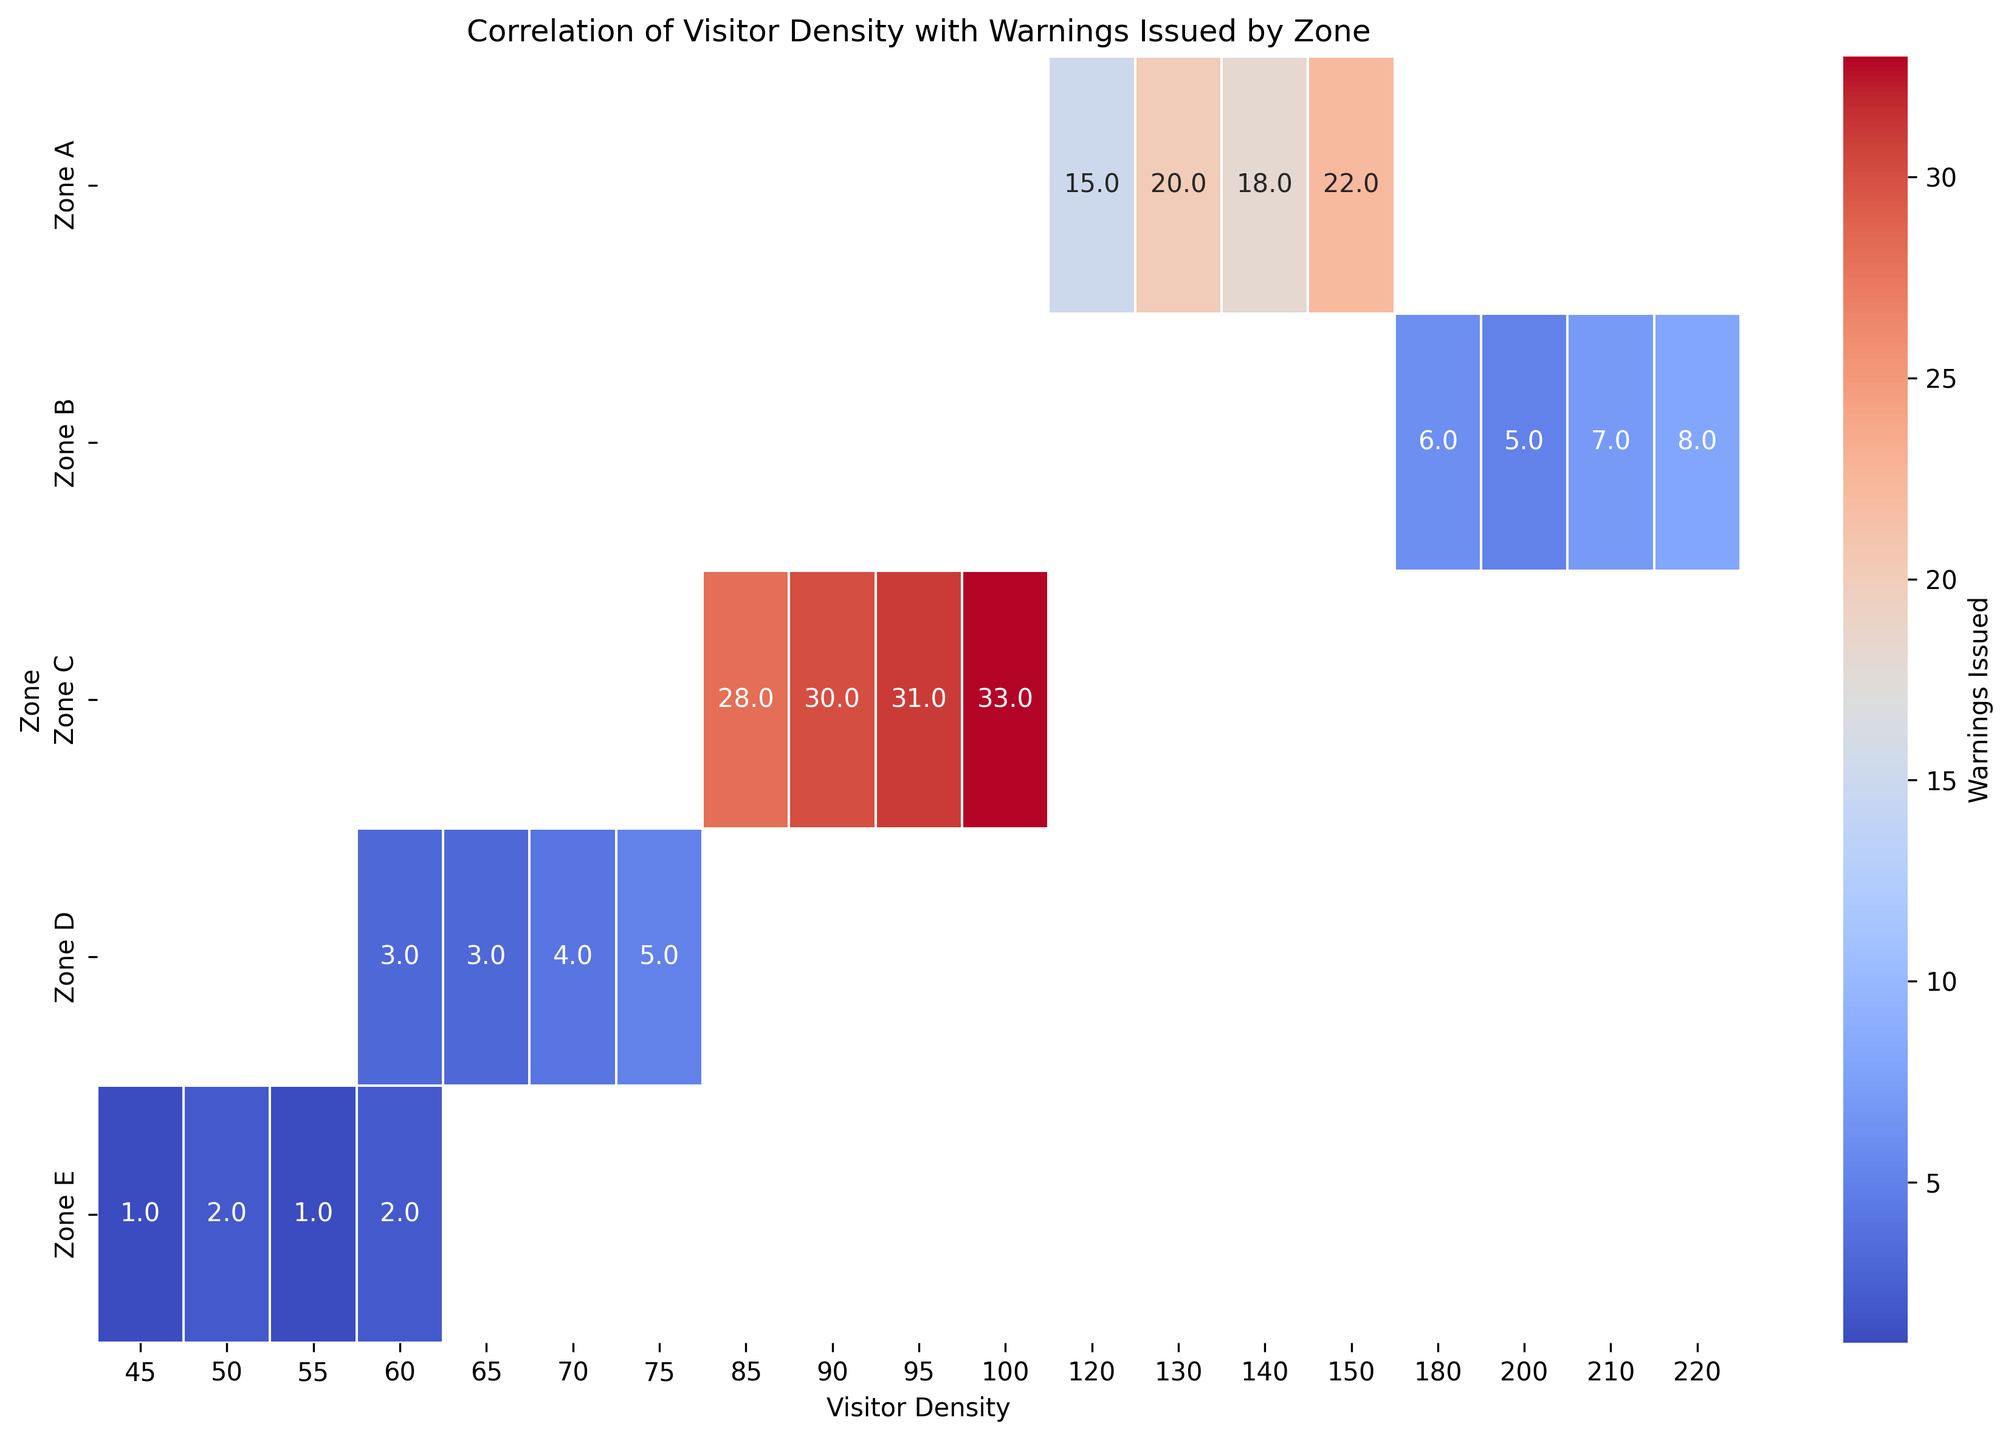Which zone has the highest average warnings issued? By looking at the heatmap, we can identify the average number of warnings issued for each zone by examining the color intensity and numerical values annotated in the cells. Zone C consistently has higher warning values compared to other zones.
Answer: Zone C In Zone B, which visitor density level corresponds to the highest number of warnings issued? We need to locate Zone B on the y-axis and find the cell with the highest numeric value for warnings issued across different visitor density levels. The highest value for Zone B is 220 visitor density with 8 warnings issued.
Answer: 220 How does the number of warnings issued in Zone D for 60 visitor density compare to 70 visitor density? By observing the cells in Zone D row corresponding to 60 and 70 visitor densities, we can compare the numbers. For 60 visitor density, 3 warnings are issued; for 70 visitor density, 4 warnings are issued. So, 4 is greater than 3.
Answer: 4 warnings is higher than 3 warnings What is the approximate average number of warnings issued in Zone A? We can calculate the average by summing the warnings for Zone A and dividing by the number of entries. The warnings are 15, 18, 20, 22. The sum is 15 + 18 + 20 + 22 = 75. The average is 75 / 4 = 18.75 warnings.
Answer: 18.75 Between Zones C and E, which has the higher median number of warnings issued? We identify the warnings for each Zone and calculate the median. Zone C: 30, 28, 33, 31; median is (30 + 31) / 2 = 30.5. Zone E: 2, 1, 1, 2; median is (1 + 2) / 2 = 1.5. Zone C has a higher median warning number.
Answer: Zone C What color gradient represents the highest number of warnings issued in the heatmap? By understanding that higher warning issuance corresponds to a certain color in the heatmap, we see that the cells with highest warnings (e.g., 33 in Zone C) have a darker (more intense) color in the "coolwarm" palette used.
Answer: Darker red Which zone received the least number of warnings on average? By examining the annotations on the heatmap and comparing the average values, Zone E has consistently low numbers: 2, 1, 1, 2. The average is (2 + 1 + 1 + 2) / 4 = 1.5.
Answer: Zone E 